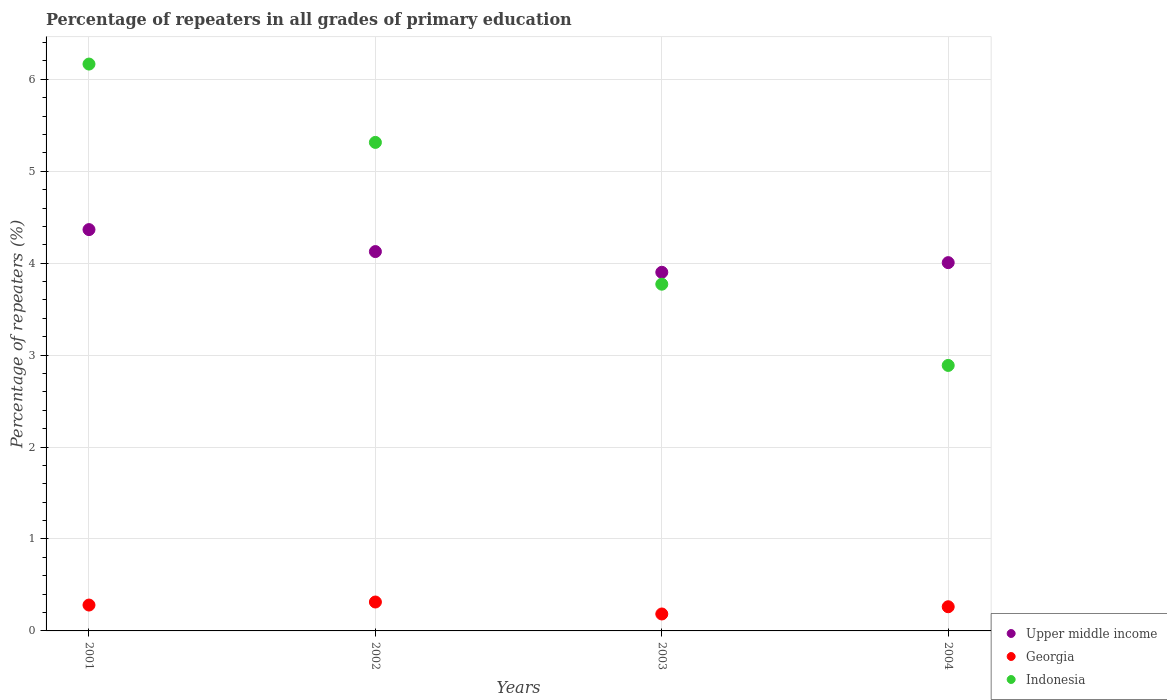What is the percentage of repeaters in Georgia in 2004?
Your answer should be compact. 0.26. Across all years, what is the maximum percentage of repeaters in Indonesia?
Give a very brief answer. 6.17. Across all years, what is the minimum percentage of repeaters in Upper middle income?
Give a very brief answer. 3.9. In which year was the percentage of repeaters in Indonesia maximum?
Keep it short and to the point. 2001. What is the total percentage of repeaters in Indonesia in the graph?
Offer a very short reply. 18.14. What is the difference between the percentage of repeaters in Indonesia in 2002 and that in 2003?
Give a very brief answer. 1.54. What is the difference between the percentage of repeaters in Upper middle income in 2002 and the percentage of repeaters in Indonesia in 2003?
Ensure brevity in your answer.  0.35. What is the average percentage of repeaters in Upper middle income per year?
Offer a terse response. 4.1. In the year 2003, what is the difference between the percentage of repeaters in Georgia and percentage of repeaters in Indonesia?
Your answer should be very brief. -3.59. What is the ratio of the percentage of repeaters in Upper middle income in 2002 to that in 2004?
Offer a very short reply. 1.03. What is the difference between the highest and the second highest percentage of repeaters in Georgia?
Provide a succinct answer. 0.03. What is the difference between the highest and the lowest percentage of repeaters in Indonesia?
Keep it short and to the point. 3.28. In how many years, is the percentage of repeaters in Georgia greater than the average percentage of repeaters in Georgia taken over all years?
Keep it short and to the point. 3. Is the sum of the percentage of repeaters in Georgia in 2001 and 2004 greater than the maximum percentage of repeaters in Upper middle income across all years?
Ensure brevity in your answer.  No. How many years are there in the graph?
Make the answer very short. 4. Where does the legend appear in the graph?
Your answer should be very brief. Bottom right. How many legend labels are there?
Provide a succinct answer. 3. What is the title of the graph?
Your response must be concise. Percentage of repeaters in all grades of primary education. What is the label or title of the Y-axis?
Offer a terse response. Percentage of repeaters (%). What is the Percentage of repeaters (%) of Upper middle income in 2001?
Keep it short and to the point. 4.37. What is the Percentage of repeaters (%) in Georgia in 2001?
Offer a terse response. 0.28. What is the Percentage of repeaters (%) of Indonesia in 2001?
Provide a short and direct response. 6.17. What is the Percentage of repeaters (%) of Upper middle income in 2002?
Make the answer very short. 4.13. What is the Percentage of repeaters (%) in Georgia in 2002?
Make the answer very short. 0.31. What is the Percentage of repeaters (%) in Indonesia in 2002?
Provide a succinct answer. 5.31. What is the Percentage of repeaters (%) in Upper middle income in 2003?
Provide a succinct answer. 3.9. What is the Percentage of repeaters (%) in Georgia in 2003?
Your answer should be very brief. 0.18. What is the Percentage of repeaters (%) of Indonesia in 2003?
Offer a terse response. 3.77. What is the Percentage of repeaters (%) of Upper middle income in 2004?
Offer a terse response. 4.01. What is the Percentage of repeaters (%) in Georgia in 2004?
Your answer should be compact. 0.26. What is the Percentage of repeaters (%) of Indonesia in 2004?
Keep it short and to the point. 2.89. Across all years, what is the maximum Percentage of repeaters (%) in Upper middle income?
Ensure brevity in your answer.  4.37. Across all years, what is the maximum Percentage of repeaters (%) in Georgia?
Give a very brief answer. 0.31. Across all years, what is the maximum Percentage of repeaters (%) in Indonesia?
Offer a very short reply. 6.17. Across all years, what is the minimum Percentage of repeaters (%) of Upper middle income?
Make the answer very short. 3.9. Across all years, what is the minimum Percentage of repeaters (%) in Georgia?
Make the answer very short. 0.18. Across all years, what is the minimum Percentage of repeaters (%) of Indonesia?
Ensure brevity in your answer.  2.89. What is the total Percentage of repeaters (%) of Upper middle income in the graph?
Offer a terse response. 16.4. What is the total Percentage of repeaters (%) of Georgia in the graph?
Your answer should be compact. 1.04. What is the total Percentage of repeaters (%) in Indonesia in the graph?
Provide a short and direct response. 18.14. What is the difference between the Percentage of repeaters (%) in Upper middle income in 2001 and that in 2002?
Your answer should be compact. 0.24. What is the difference between the Percentage of repeaters (%) in Georgia in 2001 and that in 2002?
Provide a succinct answer. -0.03. What is the difference between the Percentage of repeaters (%) in Indonesia in 2001 and that in 2002?
Your answer should be very brief. 0.85. What is the difference between the Percentage of repeaters (%) of Upper middle income in 2001 and that in 2003?
Make the answer very short. 0.46. What is the difference between the Percentage of repeaters (%) in Georgia in 2001 and that in 2003?
Give a very brief answer. 0.1. What is the difference between the Percentage of repeaters (%) of Indonesia in 2001 and that in 2003?
Provide a short and direct response. 2.39. What is the difference between the Percentage of repeaters (%) in Upper middle income in 2001 and that in 2004?
Offer a very short reply. 0.36. What is the difference between the Percentage of repeaters (%) of Georgia in 2001 and that in 2004?
Offer a terse response. 0.02. What is the difference between the Percentage of repeaters (%) in Indonesia in 2001 and that in 2004?
Your answer should be very brief. 3.28. What is the difference between the Percentage of repeaters (%) in Upper middle income in 2002 and that in 2003?
Keep it short and to the point. 0.23. What is the difference between the Percentage of repeaters (%) in Georgia in 2002 and that in 2003?
Offer a terse response. 0.13. What is the difference between the Percentage of repeaters (%) of Indonesia in 2002 and that in 2003?
Your answer should be compact. 1.54. What is the difference between the Percentage of repeaters (%) in Upper middle income in 2002 and that in 2004?
Ensure brevity in your answer.  0.12. What is the difference between the Percentage of repeaters (%) in Georgia in 2002 and that in 2004?
Provide a succinct answer. 0.05. What is the difference between the Percentage of repeaters (%) in Indonesia in 2002 and that in 2004?
Ensure brevity in your answer.  2.43. What is the difference between the Percentage of repeaters (%) in Upper middle income in 2003 and that in 2004?
Provide a succinct answer. -0.1. What is the difference between the Percentage of repeaters (%) in Georgia in 2003 and that in 2004?
Keep it short and to the point. -0.08. What is the difference between the Percentage of repeaters (%) of Indonesia in 2003 and that in 2004?
Your response must be concise. 0.88. What is the difference between the Percentage of repeaters (%) of Upper middle income in 2001 and the Percentage of repeaters (%) of Georgia in 2002?
Offer a terse response. 4.05. What is the difference between the Percentage of repeaters (%) of Upper middle income in 2001 and the Percentage of repeaters (%) of Indonesia in 2002?
Your answer should be very brief. -0.95. What is the difference between the Percentage of repeaters (%) of Georgia in 2001 and the Percentage of repeaters (%) of Indonesia in 2002?
Your answer should be compact. -5.03. What is the difference between the Percentage of repeaters (%) in Upper middle income in 2001 and the Percentage of repeaters (%) in Georgia in 2003?
Your response must be concise. 4.18. What is the difference between the Percentage of repeaters (%) in Upper middle income in 2001 and the Percentage of repeaters (%) in Indonesia in 2003?
Keep it short and to the point. 0.59. What is the difference between the Percentage of repeaters (%) in Georgia in 2001 and the Percentage of repeaters (%) in Indonesia in 2003?
Make the answer very short. -3.49. What is the difference between the Percentage of repeaters (%) in Upper middle income in 2001 and the Percentage of repeaters (%) in Georgia in 2004?
Provide a short and direct response. 4.1. What is the difference between the Percentage of repeaters (%) in Upper middle income in 2001 and the Percentage of repeaters (%) in Indonesia in 2004?
Offer a very short reply. 1.48. What is the difference between the Percentage of repeaters (%) of Georgia in 2001 and the Percentage of repeaters (%) of Indonesia in 2004?
Offer a very short reply. -2.61. What is the difference between the Percentage of repeaters (%) in Upper middle income in 2002 and the Percentage of repeaters (%) in Georgia in 2003?
Provide a short and direct response. 3.94. What is the difference between the Percentage of repeaters (%) in Upper middle income in 2002 and the Percentage of repeaters (%) in Indonesia in 2003?
Provide a short and direct response. 0.35. What is the difference between the Percentage of repeaters (%) in Georgia in 2002 and the Percentage of repeaters (%) in Indonesia in 2003?
Ensure brevity in your answer.  -3.46. What is the difference between the Percentage of repeaters (%) in Upper middle income in 2002 and the Percentage of repeaters (%) in Georgia in 2004?
Provide a succinct answer. 3.86. What is the difference between the Percentage of repeaters (%) of Upper middle income in 2002 and the Percentage of repeaters (%) of Indonesia in 2004?
Keep it short and to the point. 1.24. What is the difference between the Percentage of repeaters (%) of Georgia in 2002 and the Percentage of repeaters (%) of Indonesia in 2004?
Your response must be concise. -2.57. What is the difference between the Percentage of repeaters (%) of Upper middle income in 2003 and the Percentage of repeaters (%) of Georgia in 2004?
Ensure brevity in your answer.  3.64. What is the difference between the Percentage of repeaters (%) of Upper middle income in 2003 and the Percentage of repeaters (%) of Indonesia in 2004?
Ensure brevity in your answer.  1.01. What is the difference between the Percentage of repeaters (%) of Georgia in 2003 and the Percentage of repeaters (%) of Indonesia in 2004?
Provide a succinct answer. -2.7. What is the average Percentage of repeaters (%) of Georgia per year?
Your response must be concise. 0.26. What is the average Percentage of repeaters (%) in Indonesia per year?
Offer a terse response. 4.54. In the year 2001, what is the difference between the Percentage of repeaters (%) of Upper middle income and Percentage of repeaters (%) of Georgia?
Your answer should be compact. 4.08. In the year 2001, what is the difference between the Percentage of repeaters (%) in Upper middle income and Percentage of repeaters (%) in Indonesia?
Offer a very short reply. -1.8. In the year 2001, what is the difference between the Percentage of repeaters (%) of Georgia and Percentage of repeaters (%) of Indonesia?
Ensure brevity in your answer.  -5.88. In the year 2002, what is the difference between the Percentage of repeaters (%) of Upper middle income and Percentage of repeaters (%) of Georgia?
Your response must be concise. 3.81. In the year 2002, what is the difference between the Percentage of repeaters (%) of Upper middle income and Percentage of repeaters (%) of Indonesia?
Ensure brevity in your answer.  -1.19. In the year 2002, what is the difference between the Percentage of repeaters (%) of Georgia and Percentage of repeaters (%) of Indonesia?
Keep it short and to the point. -5. In the year 2003, what is the difference between the Percentage of repeaters (%) in Upper middle income and Percentage of repeaters (%) in Georgia?
Offer a very short reply. 3.72. In the year 2003, what is the difference between the Percentage of repeaters (%) of Upper middle income and Percentage of repeaters (%) of Indonesia?
Ensure brevity in your answer.  0.13. In the year 2003, what is the difference between the Percentage of repeaters (%) of Georgia and Percentage of repeaters (%) of Indonesia?
Provide a short and direct response. -3.59. In the year 2004, what is the difference between the Percentage of repeaters (%) in Upper middle income and Percentage of repeaters (%) in Georgia?
Offer a very short reply. 3.74. In the year 2004, what is the difference between the Percentage of repeaters (%) in Upper middle income and Percentage of repeaters (%) in Indonesia?
Your answer should be very brief. 1.12. In the year 2004, what is the difference between the Percentage of repeaters (%) of Georgia and Percentage of repeaters (%) of Indonesia?
Make the answer very short. -2.63. What is the ratio of the Percentage of repeaters (%) of Upper middle income in 2001 to that in 2002?
Make the answer very short. 1.06. What is the ratio of the Percentage of repeaters (%) in Georgia in 2001 to that in 2002?
Offer a terse response. 0.9. What is the ratio of the Percentage of repeaters (%) of Indonesia in 2001 to that in 2002?
Give a very brief answer. 1.16. What is the ratio of the Percentage of repeaters (%) of Upper middle income in 2001 to that in 2003?
Give a very brief answer. 1.12. What is the ratio of the Percentage of repeaters (%) in Georgia in 2001 to that in 2003?
Offer a terse response. 1.53. What is the ratio of the Percentage of repeaters (%) of Indonesia in 2001 to that in 2003?
Your answer should be very brief. 1.63. What is the ratio of the Percentage of repeaters (%) in Upper middle income in 2001 to that in 2004?
Give a very brief answer. 1.09. What is the ratio of the Percentage of repeaters (%) in Georgia in 2001 to that in 2004?
Your response must be concise. 1.07. What is the ratio of the Percentage of repeaters (%) of Indonesia in 2001 to that in 2004?
Provide a short and direct response. 2.14. What is the ratio of the Percentage of repeaters (%) in Upper middle income in 2002 to that in 2003?
Your answer should be compact. 1.06. What is the ratio of the Percentage of repeaters (%) of Georgia in 2002 to that in 2003?
Give a very brief answer. 1.71. What is the ratio of the Percentage of repeaters (%) in Indonesia in 2002 to that in 2003?
Keep it short and to the point. 1.41. What is the ratio of the Percentage of repeaters (%) in Upper middle income in 2002 to that in 2004?
Give a very brief answer. 1.03. What is the ratio of the Percentage of repeaters (%) of Georgia in 2002 to that in 2004?
Your answer should be compact. 1.2. What is the ratio of the Percentage of repeaters (%) in Indonesia in 2002 to that in 2004?
Provide a succinct answer. 1.84. What is the ratio of the Percentage of repeaters (%) of Upper middle income in 2003 to that in 2004?
Provide a short and direct response. 0.97. What is the ratio of the Percentage of repeaters (%) in Georgia in 2003 to that in 2004?
Your answer should be compact. 0.7. What is the ratio of the Percentage of repeaters (%) of Indonesia in 2003 to that in 2004?
Ensure brevity in your answer.  1.31. What is the difference between the highest and the second highest Percentage of repeaters (%) of Upper middle income?
Offer a terse response. 0.24. What is the difference between the highest and the second highest Percentage of repeaters (%) in Georgia?
Offer a terse response. 0.03. What is the difference between the highest and the second highest Percentage of repeaters (%) in Indonesia?
Make the answer very short. 0.85. What is the difference between the highest and the lowest Percentage of repeaters (%) of Upper middle income?
Provide a short and direct response. 0.46. What is the difference between the highest and the lowest Percentage of repeaters (%) in Georgia?
Keep it short and to the point. 0.13. What is the difference between the highest and the lowest Percentage of repeaters (%) in Indonesia?
Provide a short and direct response. 3.28. 